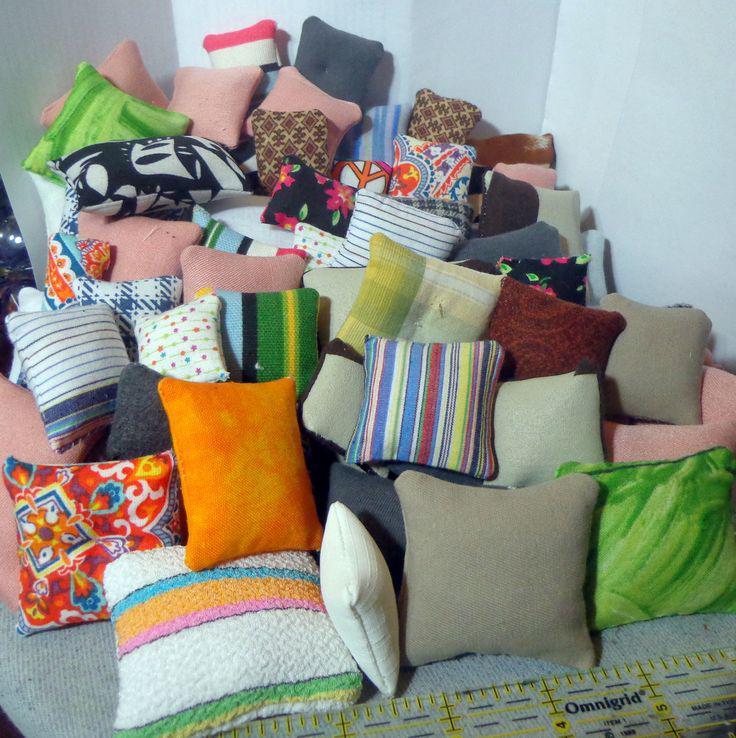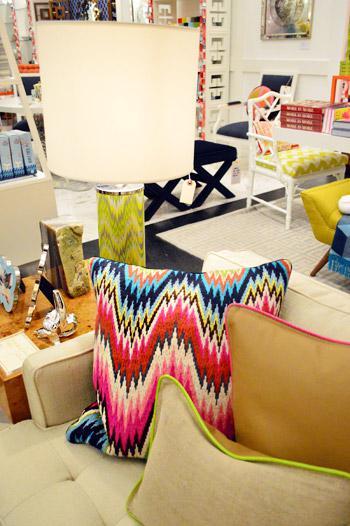The first image is the image on the left, the second image is the image on the right. Given the left and right images, does the statement "The sofa in the image on the left is buried in pillows" hold true? Answer yes or no. Yes. The first image is the image on the left, the second image is the image on the right. Examine the images to the left and right. Is the description "At least one image has no more than two pillows." accurate? Answer yes or no. No. 